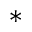Convert formula to latex. <formula><loc_0><loc_0><loc_500><loc_500>^ { * }</formula> 